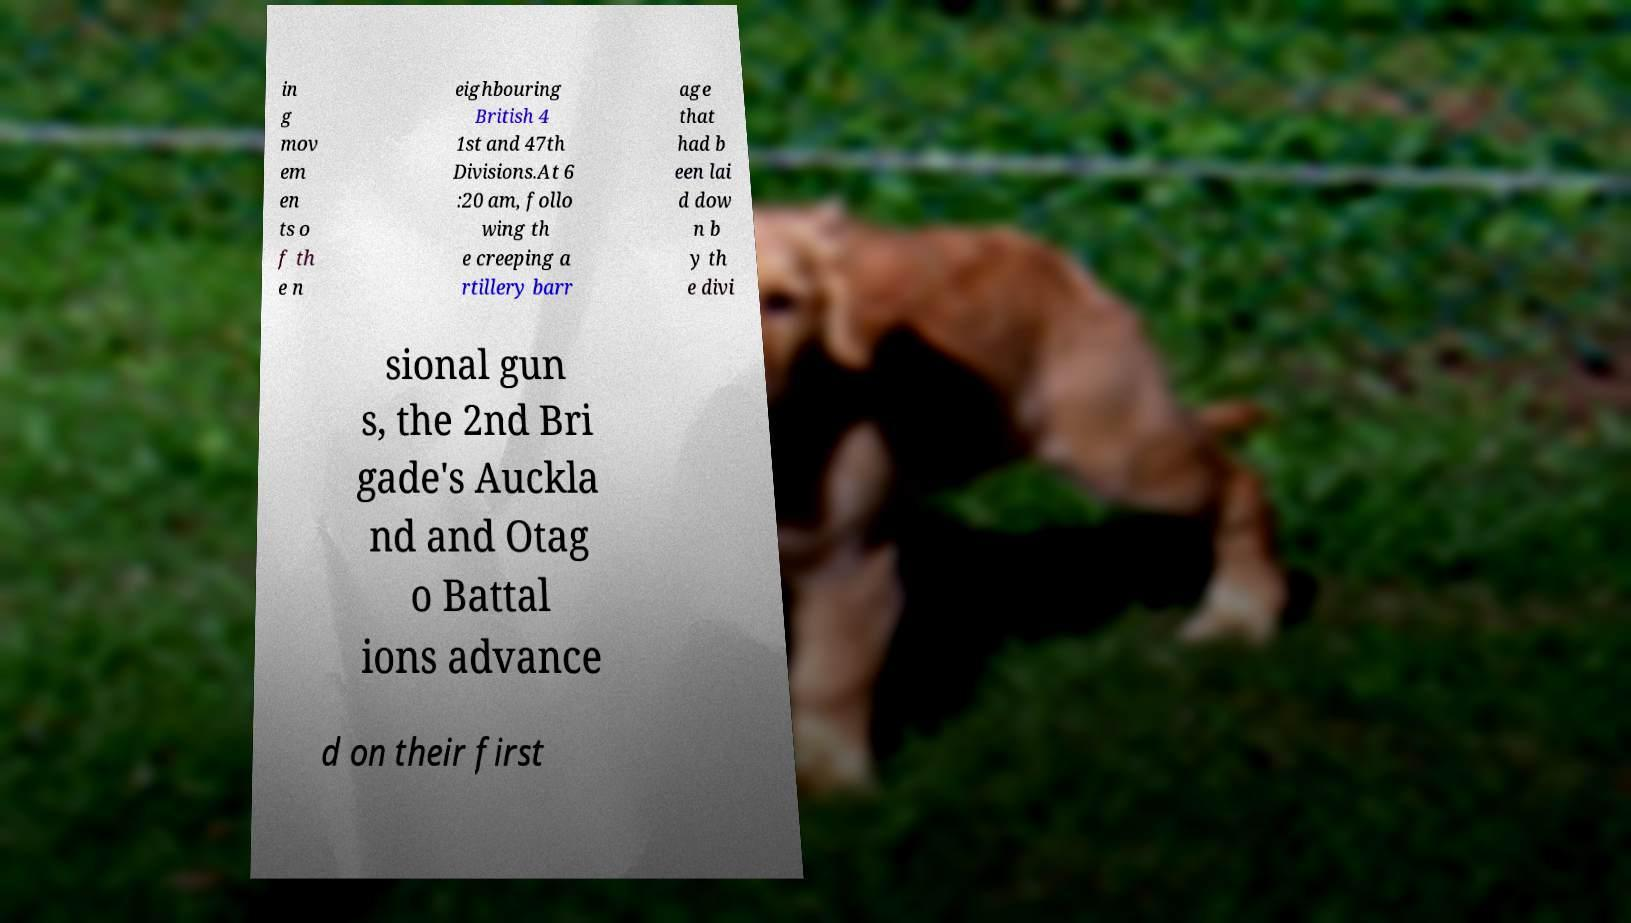Could you assist in decoding the text presented in this image and type it out clearly? in g mov em en ts o f th e n eighbouring British 4 1st and 47th Divisions.At 6 :20 am, follo wing th e creeping a rtillery barr age that had b een lai d dow n b y th e divi sional gun s, the 2nd Bri gade's Auckla nd and Otag o Battal ions advance d on their first 